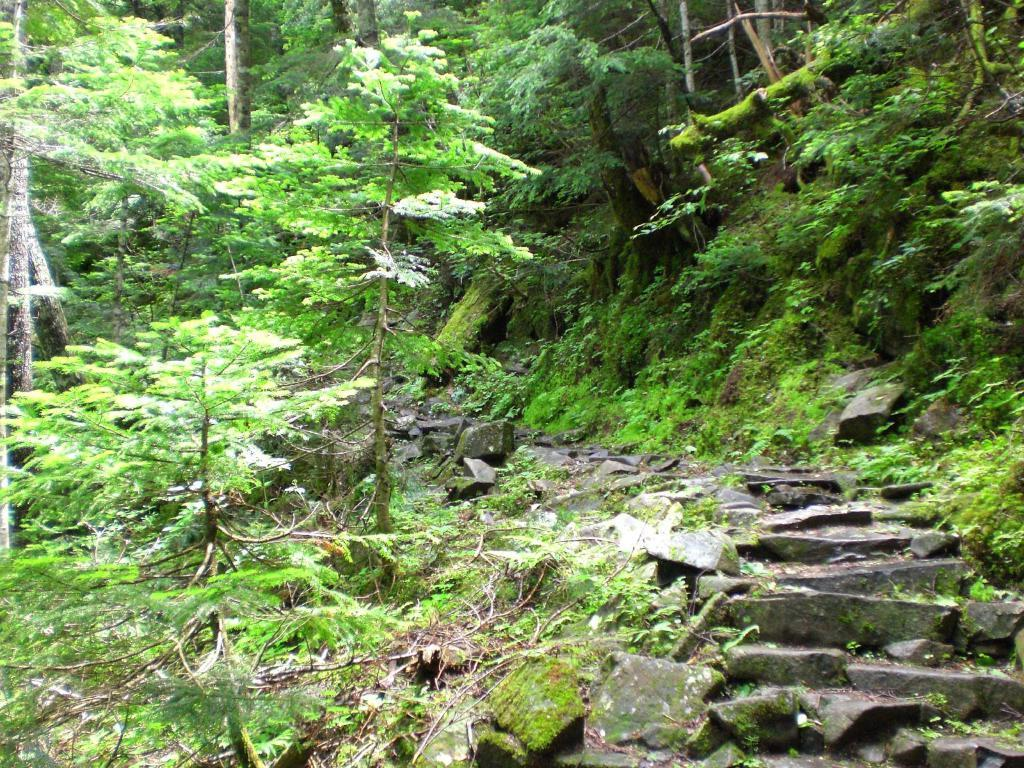What can be seen in the image that people might walk on? There is a path in the image that people might walk on. What is present on the path in the image? There are rocks on the path in the image. What type of natural environment can be seen in the background of the image? There are plants and trees in the background of the image. What type of chair can be seen in the image? There is no chair present in the image. What rhythm is being played in the background of the image? There is no music or rhythm present in the image. 